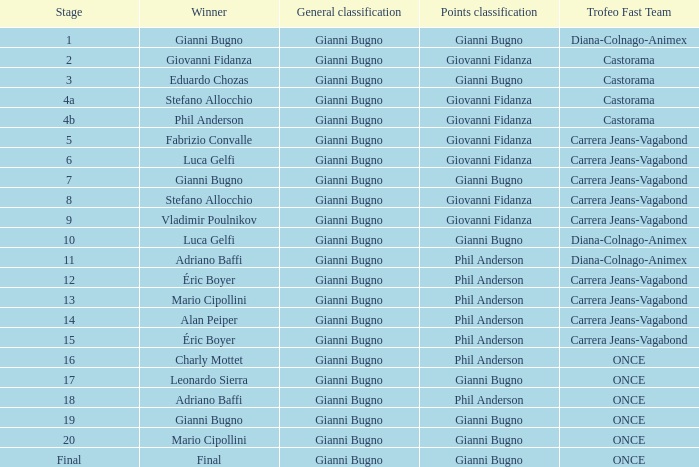Write the full table. {'header': ['Stage', 'Winner', 'General classification', 'Points classification', 'Trofeo Fast Team'], 'rows': [['1', 'Gianni Bugno', 'Gianni Bugno', 'Gianni Bugno', 'Diana-Colnago-Animex'], ['2', 'Giovanni Fidanza', 'Gianni Bugno', 'Giovanni Fidanza', 'Castorama'], ['3', 'Eduardo Chozas', 'Gianni Bugno', 'Gianni Bugno', 'Castorama'], ['4a', 'Stefano Allocchio', 'Gianni Bugno', 'Giovanni Fidanza', 'Castorama'], ['4b', 'Phil Anderson', 'Gianni Bugno', 'Giovanni Fidanza', 'Castorama'], ['5', 'Fabrizio Convalle', 'Gianni Bugno', 'Giovanni Fidanza', 'Carrera Jeans-Vagabond'], ['6', 'Luca Gelfi', 'Gianni Bugno', 'Giovanni Fidanza', 'Carrera Jeans-Vagabond'], ['7', 'Gianni Bugno', 'Gianni Bugno', 'Gianni Bugno', 'Carrera Jeans-Vagabond'], ['8', 'Stefano Allocchio', 'Gianni Bugno', 'Giovanni Fidanza', 'Carrera Jeans-Vagabond'], ['9', 'Vladimir Poulnikov', 'Gianni Bugno', 'Giovanni Fidanza', 'Carrera Jeans-Vagabond'], ['10', 'Luca Gelfi', 'Gianni Bugno', 'Gianni Bugno', 'Diana-Colnago-Animex'], ['11', 'Adriano Baffi', 'Gianni Bugno', 'Phil Anderson', 'Diana-Colnago-Animex'], ['12', 'Éric Boyer', 'Gianni Bugno', 'Phil Anderson', 'Carrera Jeans-Vagabond'], ['13', 'Mario Cipollini', 'Gianni Bugno', 'Phil Anderson', 'Carrera Jeans-Vagabond'], ['14', 'Alan Peiper', 'Gianni Bugno', 'Phil Anderson', 'Carrera Jeans-Vagabond'], ['15', 'Éric Boyer', 'Gianni Bugno', 'Phil Anderson', 'Carrera Jeans-Vagabond'], ['16', 'Charly Mottet', 'Gianni Bugno', 'Phil Anderson', 'ONCE'], ['17', 'Leonardo Sierra', 'Gianni Bugno', 'Gianni Bugno', 'ONCE'], ['18', 'Adriano Baffi', 'Gianni Bugno', 'Phil Anderson', 'ONCE'], ['19', 'Gianni Bugno', 'Gianni Bugno', 'Gianni Bugno', 'ONCE'], ['20', 'Mario Cipollini', 'Gianni Bugno', 'Gianni Bugno', 'ONCE'], ['Final', 'Final', 'Gianni Bugno', 'Gianni Bugno', 'ONCE']]} Who was the trofeo fast team in stage 10? Diana-Colnago-Animex. 